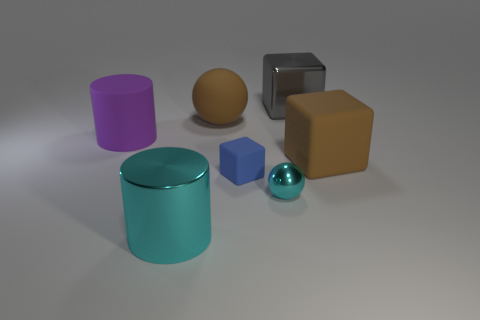Subtract all blue rubber blocks. How many blocks are left? 2 Subtract all cylinders. How many objects are left? 5 Subtract 2 blocks. How many blocks are left? 1 Subtract all cyan cylinders. Subtract all yellow blocks. How many cylinders are left? 1 Subtract all blue blocks. How many gray cylinders are left? 0 Subtract all gray shiny blocks. Subtract all cyan cylinders. How many objects are left? 5 Add 6 large shiny objects. How many large shiny objects are left? 8 Add 2 brown spheres. How many brown spheres exist? 3 Add 2 yellow shiny cubes. How many objects exist? 9 Subtract all purple cylinders. How many cylinders are left? 1 